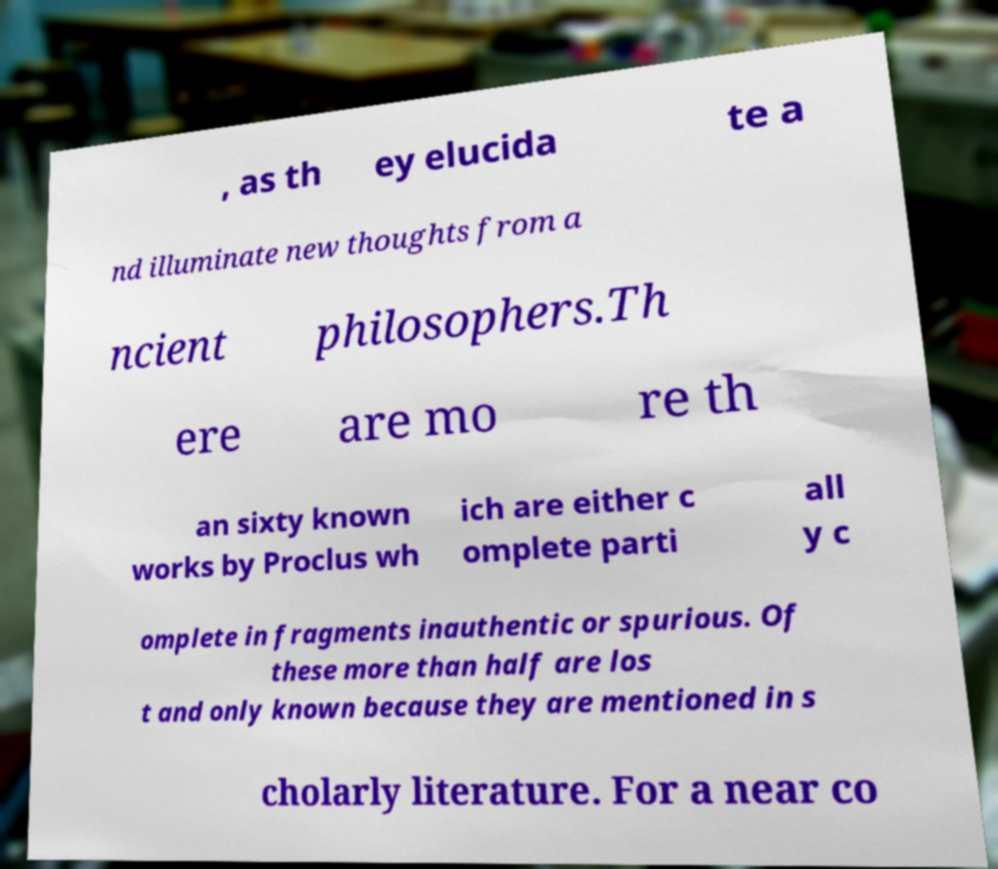There's text embedded in this image that I need extracted. Can you transcribe it verbatim? , as th ey elucida te a nd illuminate new thoughts from a ncient philosophers.Th ere are mo re th an sixty known works by Proclus wh ich are either c omplete parti all y c omplete in fragments inauthentic or spurious. Of these more than half are los t and only known because they are mentioned in s cholarly literature. For a near co 